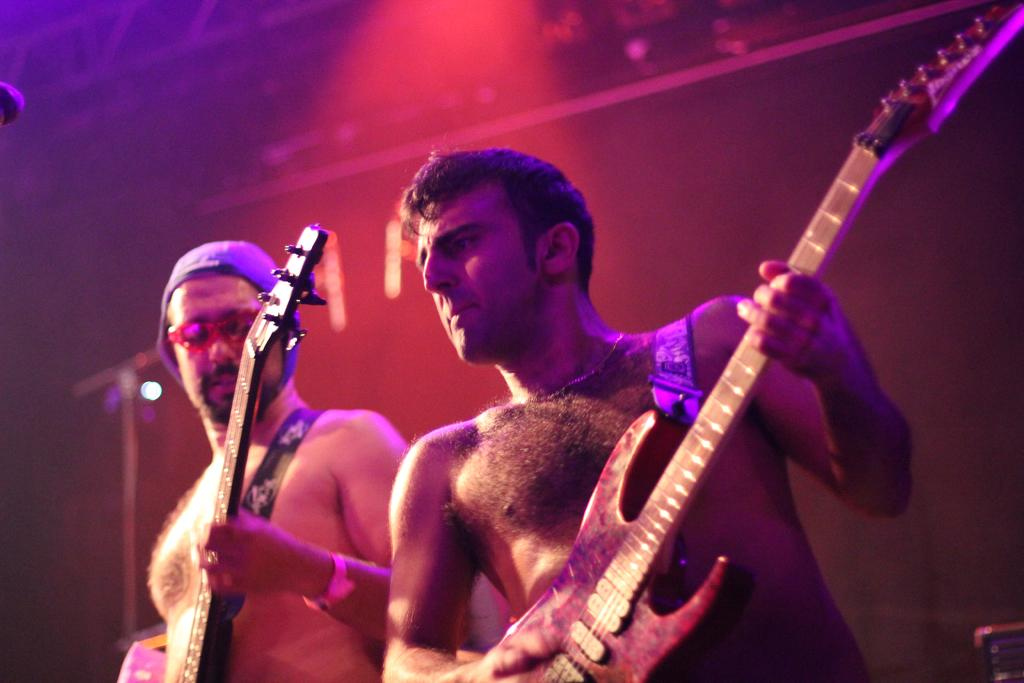How many people are in the image? There are two men standing in the image. What are the men holding in the image? The men are holding a music object. What can be seen on the right side of the image? There is a table on the right side of the image. What is visible in the background of the image? There is a wall in the background of the image. How many balloons are floating above the men in the image? There are no balloons visible in the image; the men are holding a music object. What type of boats can be seen in the image? There are no boats present in the image. 